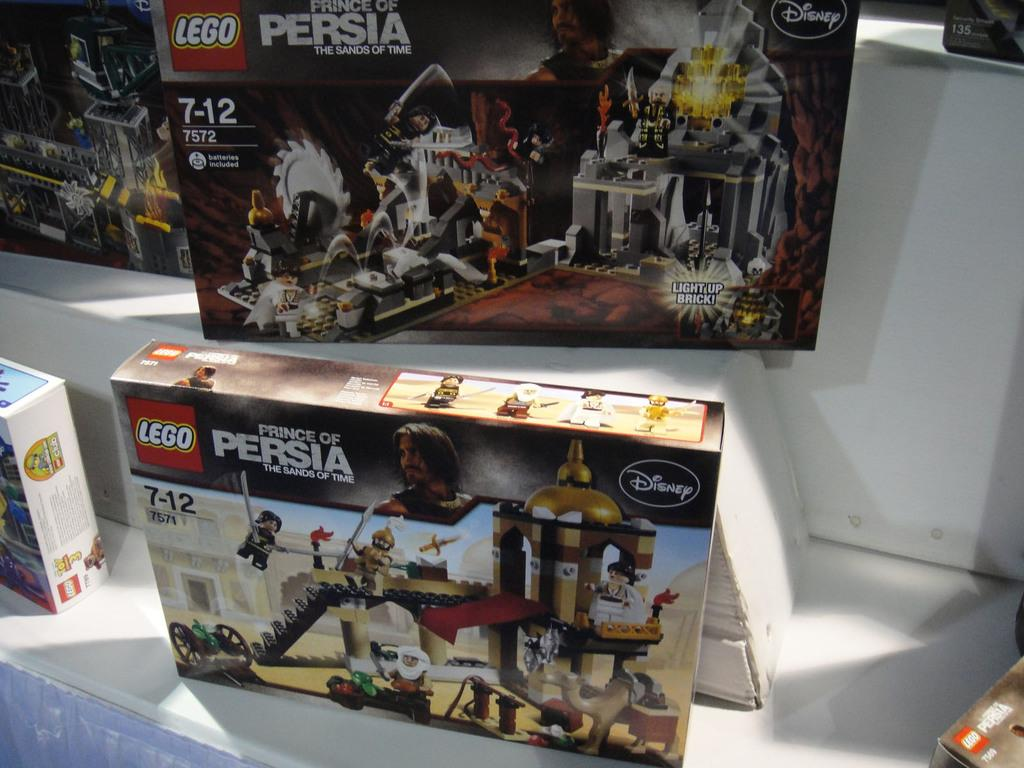What objects are present in the image? There are boxes in the image. What is depicted on the boxes? There are toy pictures on the boxes. Can you hear a whistle in the image? There is no whistle present in the image, as it is a visual medium and does not contain sound. 